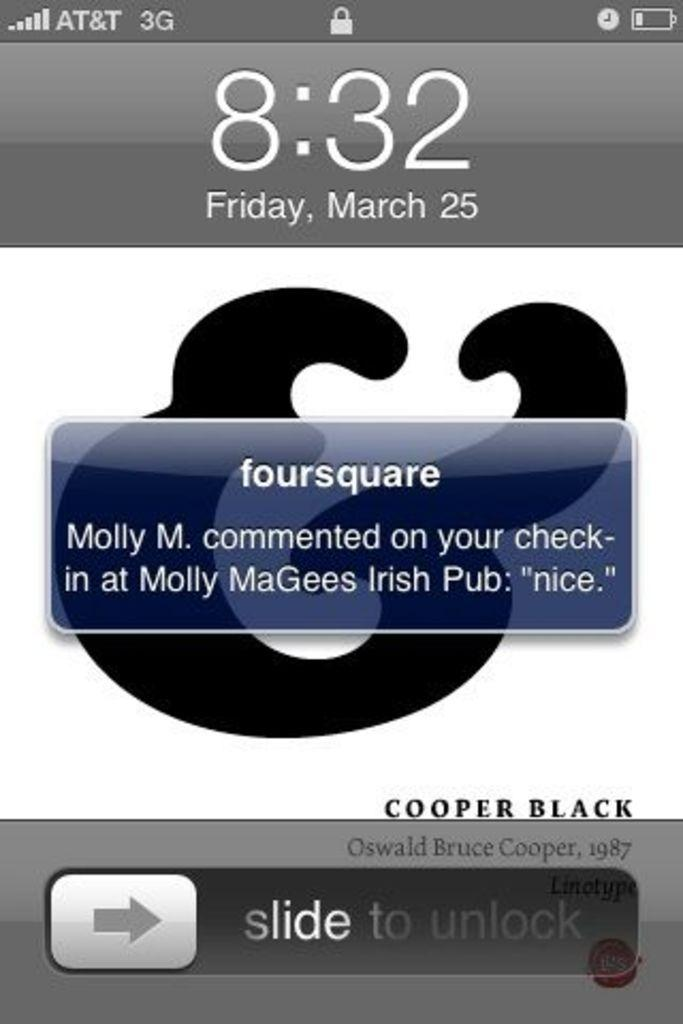<image>
Create a compact narrative representing the image presented. A screenshot of a cellphone screen gives a notification for the foursquare app that says Molly M. commented on a check-in 